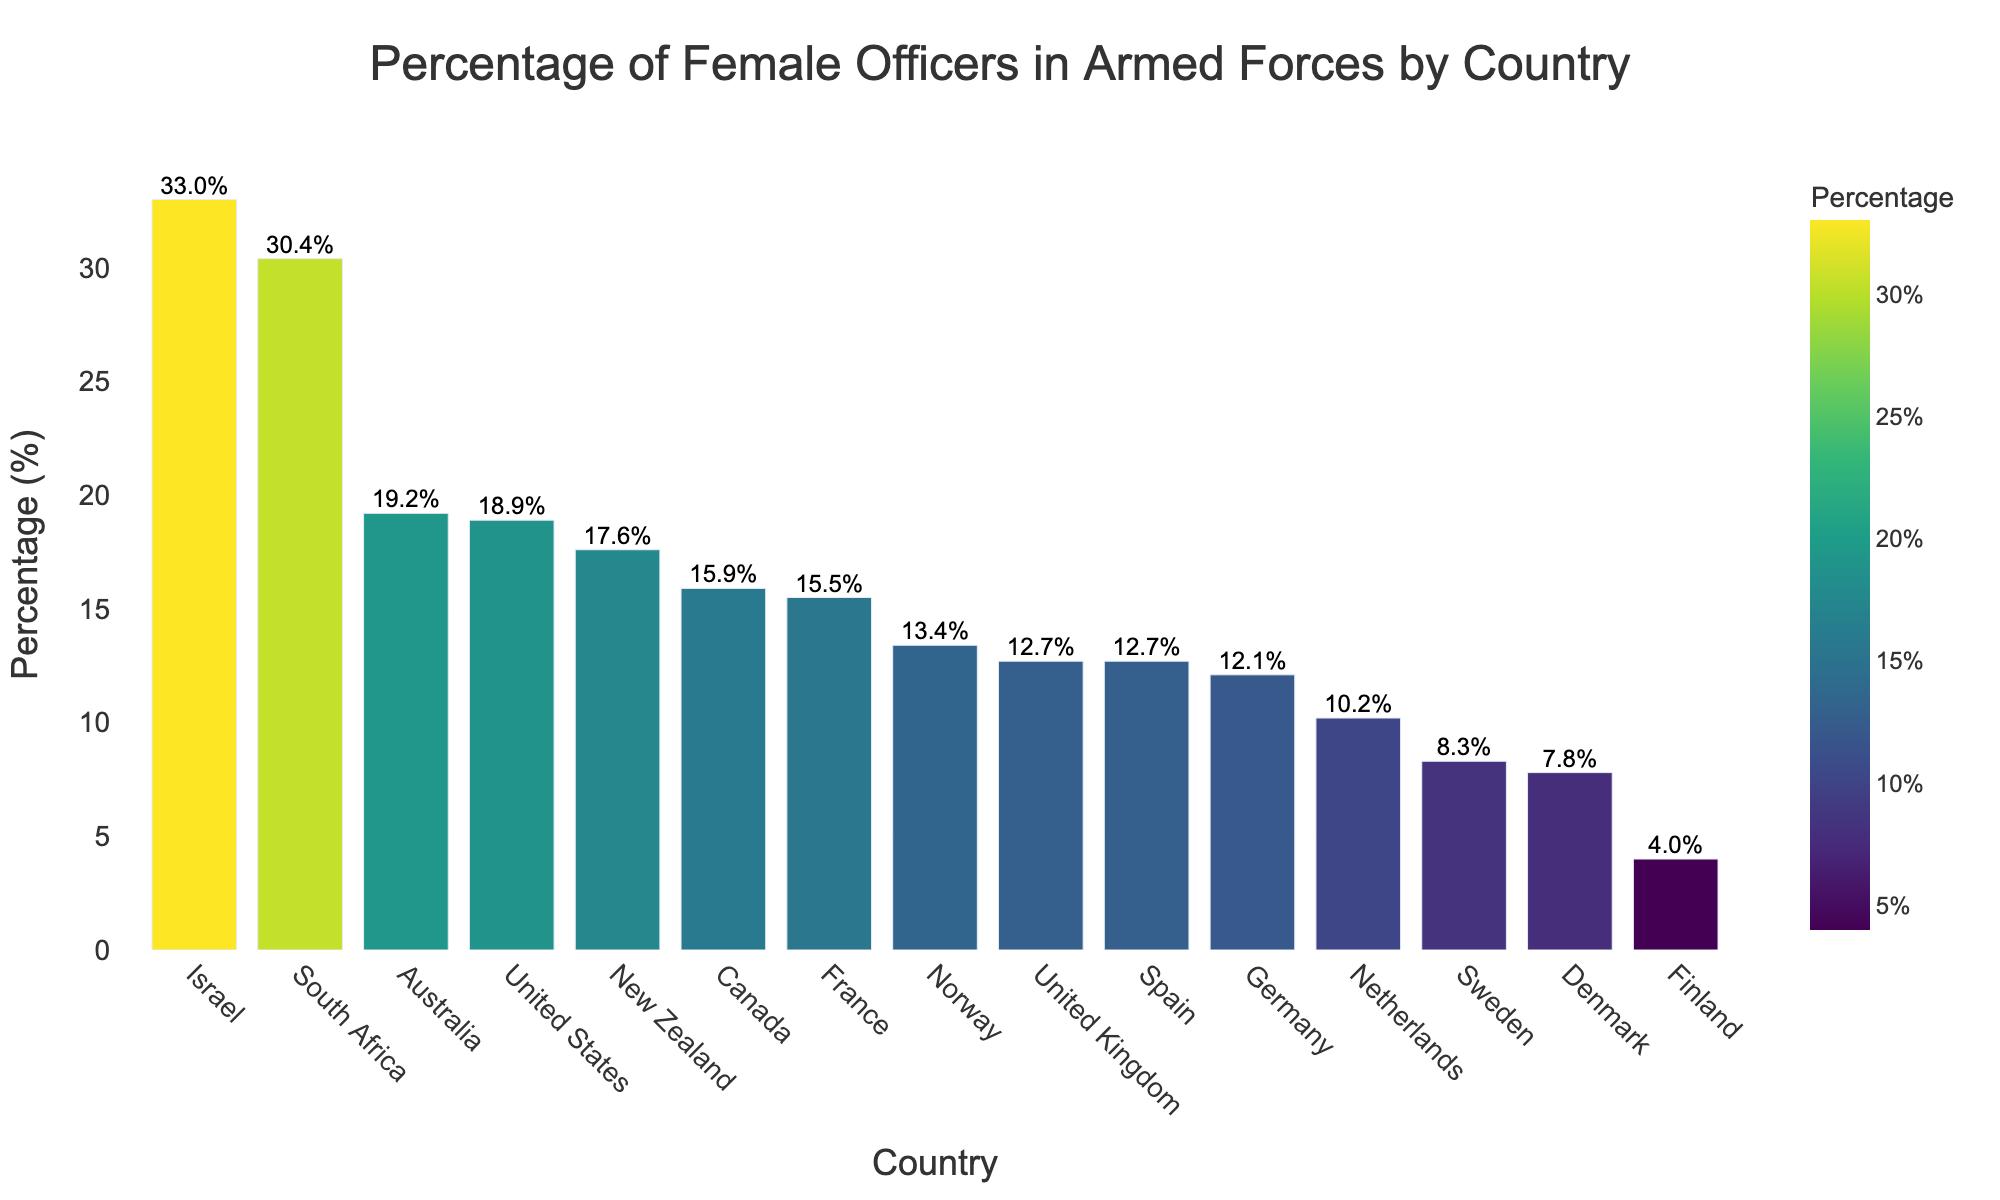Which country has the highest percentage of female officers? From the bar chart, identify the tallest bar which represents the highest percentage. The tallest bar is labeled "Israel" with a percentage of 33.0%
Answer: Israel Which country has a lower percentage of female officers: Germany or France? Compare the heights of the bars for Germany (12.1%) and France (15.5%). The bar for Germany is shorter, indicating a lower percentage
Answer: Germany What is the average percentage of female officers among the top three countries? Identify the top three countries with the highest percentages: Israel (33.0%), South Africa (30.4%), and Australia (19.2%). Calculate the average: (33.0 + 30.4 + 19.2) / 3 = 27.53%
Answer: 27.53% Which countries have a percentage of female officers greater than 15% but less than 20%? Identify countries with percentages between 15% and 20% from the bar chart: United States (18.9%), Canada (15.9%), France (15.5%), and New Zealand (17.6%)
Answer: United States, Canada, France, New Zealand How many countries have a percentage of female officers less than 10%? Count the bars that represent percentages less than 10%: Sweden (8.3%), Denmark (7.8%), and Finland (4.0%). There are three such countries
Answer: 3 countries What is the difference in percentage of female officers between the United Kingdom and the Netherlands? Subtract the percentage for the Netherlands (10.2%) from that of the United Kingdom (12.7%). The difference is 12.7% - 10.2% = 2.5%
Answer: 2.5% Which countries have percentages of female officers close to 12%? Look for bars with percentages around 12%: United Kingdom (12.7%), Spain (12.7%), and Germany (12.1%)
Answer: United Kingdom, Spain, Germany Is South Africa closer to the top or bottom of the list in terms of the percentage of female officers? Observe the ordered bars and see that South Africa (30.4%) is the second highest, placing it near the top of the list
Answer: Closer to the top What is the median percentage of female officers across all countries? List the percentages: 33.0, 30.4, 19.2, 18.9, 17.6, 15.9, 15.5, 13.4, 12.7, 12.7, 12.1, 10.2, 8.3, 7.8, 4.0. The middle value (median) of this ordered list is 13.4%
Answer: 13.4% 